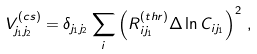Convert formula to latex. <formula><loc_0><loc_0><loc_500><loc_500>V ^ { ( c s ) } _ { j _ { 1 } j _ { 2 } } = \delta _ { j _ { 1 } j _ { 2 } } \sum _ { i } \left ( R _ { i j _ { 1 } } ^ { ( t h r ) } \Delta \ln C _ { i j _ { 1 } } \right ) ^ { 2 } \, ,</formula> 